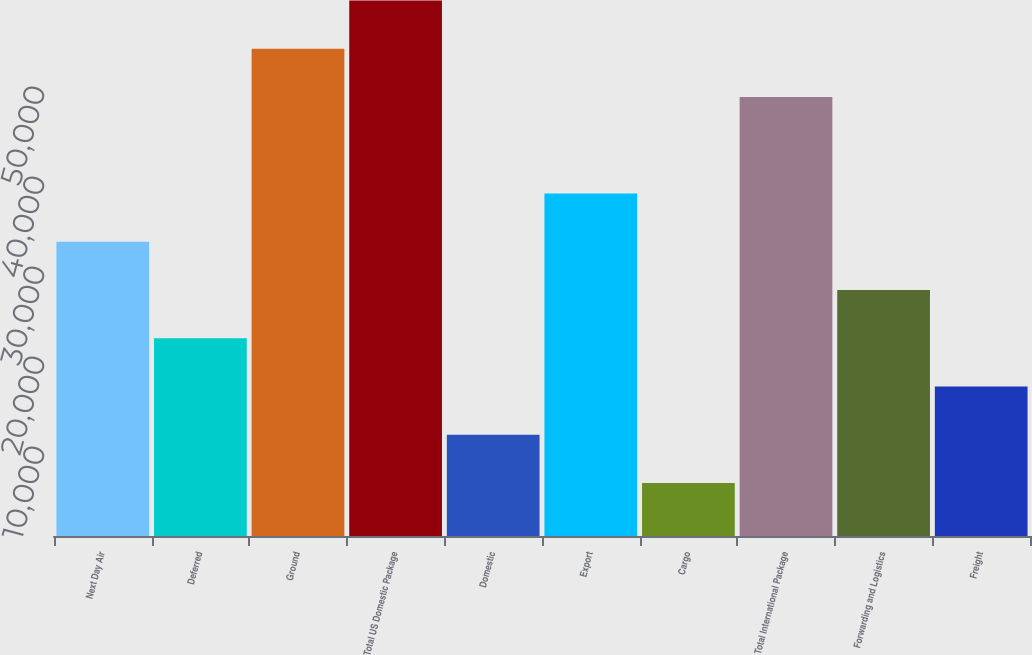Convert chart. <chart><loc_0><loc_0><loc_500><loc_500><bar_chart><fcel>Next Day Air<fcel>Deferred<fcel>Ground<fcel>Total US Domestic Package<fcel>Domestic<fcel>Export<fcel>Cargo<fcel>Total International Package<fcel>Forwarding and Logistics<fcel>Freight<nl><fcel>32688.2<fcel>21968.8<fcel>54127<fcel>59486.7<fcel>11249.4<fcel>38047.9<fcel>5889.7<fcel>48767.3<fcel>27328.5<fcel>16609.1<nl></chart> 